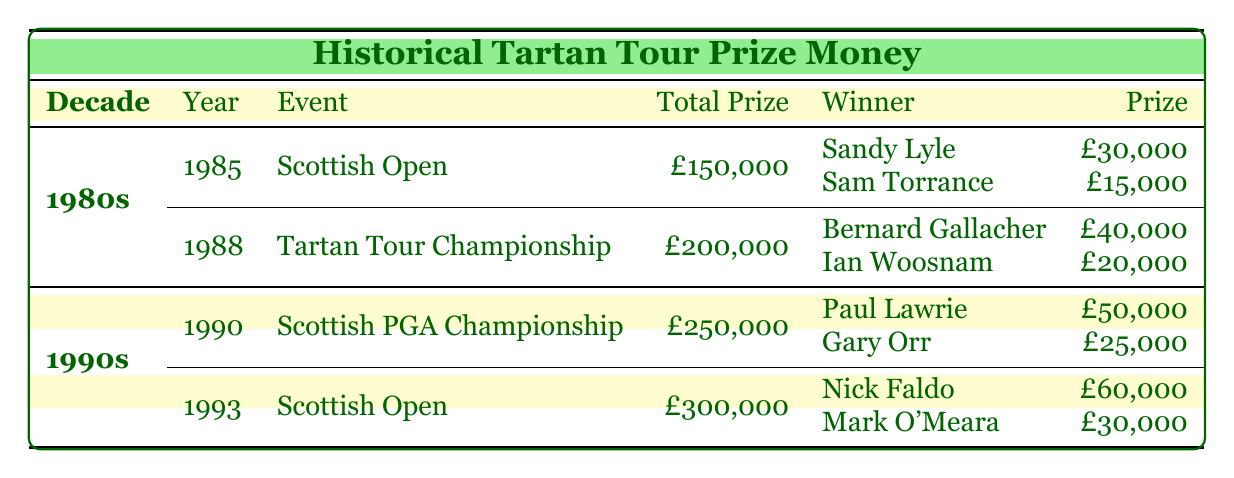What was the total prize money for the Scottish Open in 1985? According to the table, the total prize money for the Scottish Open in 1985 is listed as £150,000.
Answer: £150,000 Who won the Tartan Tour Championship in 1988? The table shows that Bernard Gallacher won the Tartan Tour Championship in 1988.
Answer: Bernard Gallacher Which two events had a higher total prize money, the Tartan Tour Championship in 1988 or the Scottish Open in 1993? The Tartan Tour Championship in 1988 had a total prize money of £200,000, while the Scottish Open in 1993 had £300,000. Since £300,000 is greater than £200,000, the Scottish Open in 1993 had a higher total prize money.
Answer: Scottish Open in 1993 Was the total prize money for the Scottish PGA Championship in 1990 greater than or equal to £250,000? The table states that the total prize money for the Scottish PGA Championship in 1990 is £250,000, which is equal to £250,000.
Answer: Yes What is the combined prize money awarded to all runners-up in the Scottish Open in 1993? To find the combined prize money for the runners-up in the Scottish Open 1993, we sum the individual prizes: Mark O'Meara received £30,000 and David Gilford received £20,000. Adding these gives us £30,000 + £20,000 = £50,000.
Answer: £50,000 Which winner had the highest prize money, and how much was it? In the table, the winners' prize money amounts are £30,000 for Sandy Lyle (1985), £40,000 for Bernard Gallacher (1988), £50,000 for Paul Lawrie (1990), and £60,000 for Nick Faldo (1993). By comparing these amounts, Nick Faldo had the highest prize money, which is £60,000.
Answer: £60,000 What was the prize money for Sam Torrance in the Scottish Open 1985? The table specifies that Sam Torrance's prize money for the Scottish Open in 1985 is £15,000.
Answer: £15,000 Is it true that Ian Woosnam was a runner-up in an event during the 1980s? The table shows that Ian Woosnam was a runner-up in the Tartan Tour Championship in 1988, so this statement is true.
Answer: Yes 